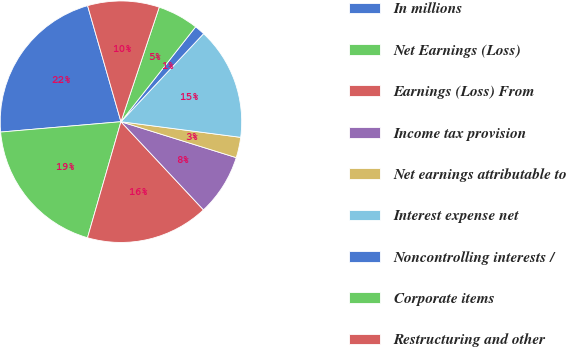<chart> <loc_0><loc_0><loc_500><loc_500><pie_chart><fcel>In millions<fcel>Net Earnings (Loss)<fcel>Earnings (Loss) From<fcel>Income tax provision<fcel>Net earnings attributable to<fcel>Interest expense net<fcel>Noncontrolling interests /<fcel>Corporate items<fcel>Restructuring and other<nl><fcel>21.91%<fcel>19.17%<fcel>16.44%<fcel>8.22%<fcel>2.74%<fcel>15.07%<fcel>1.38%<fcel>5.48%<fcel>9.59%<nl></chart> 